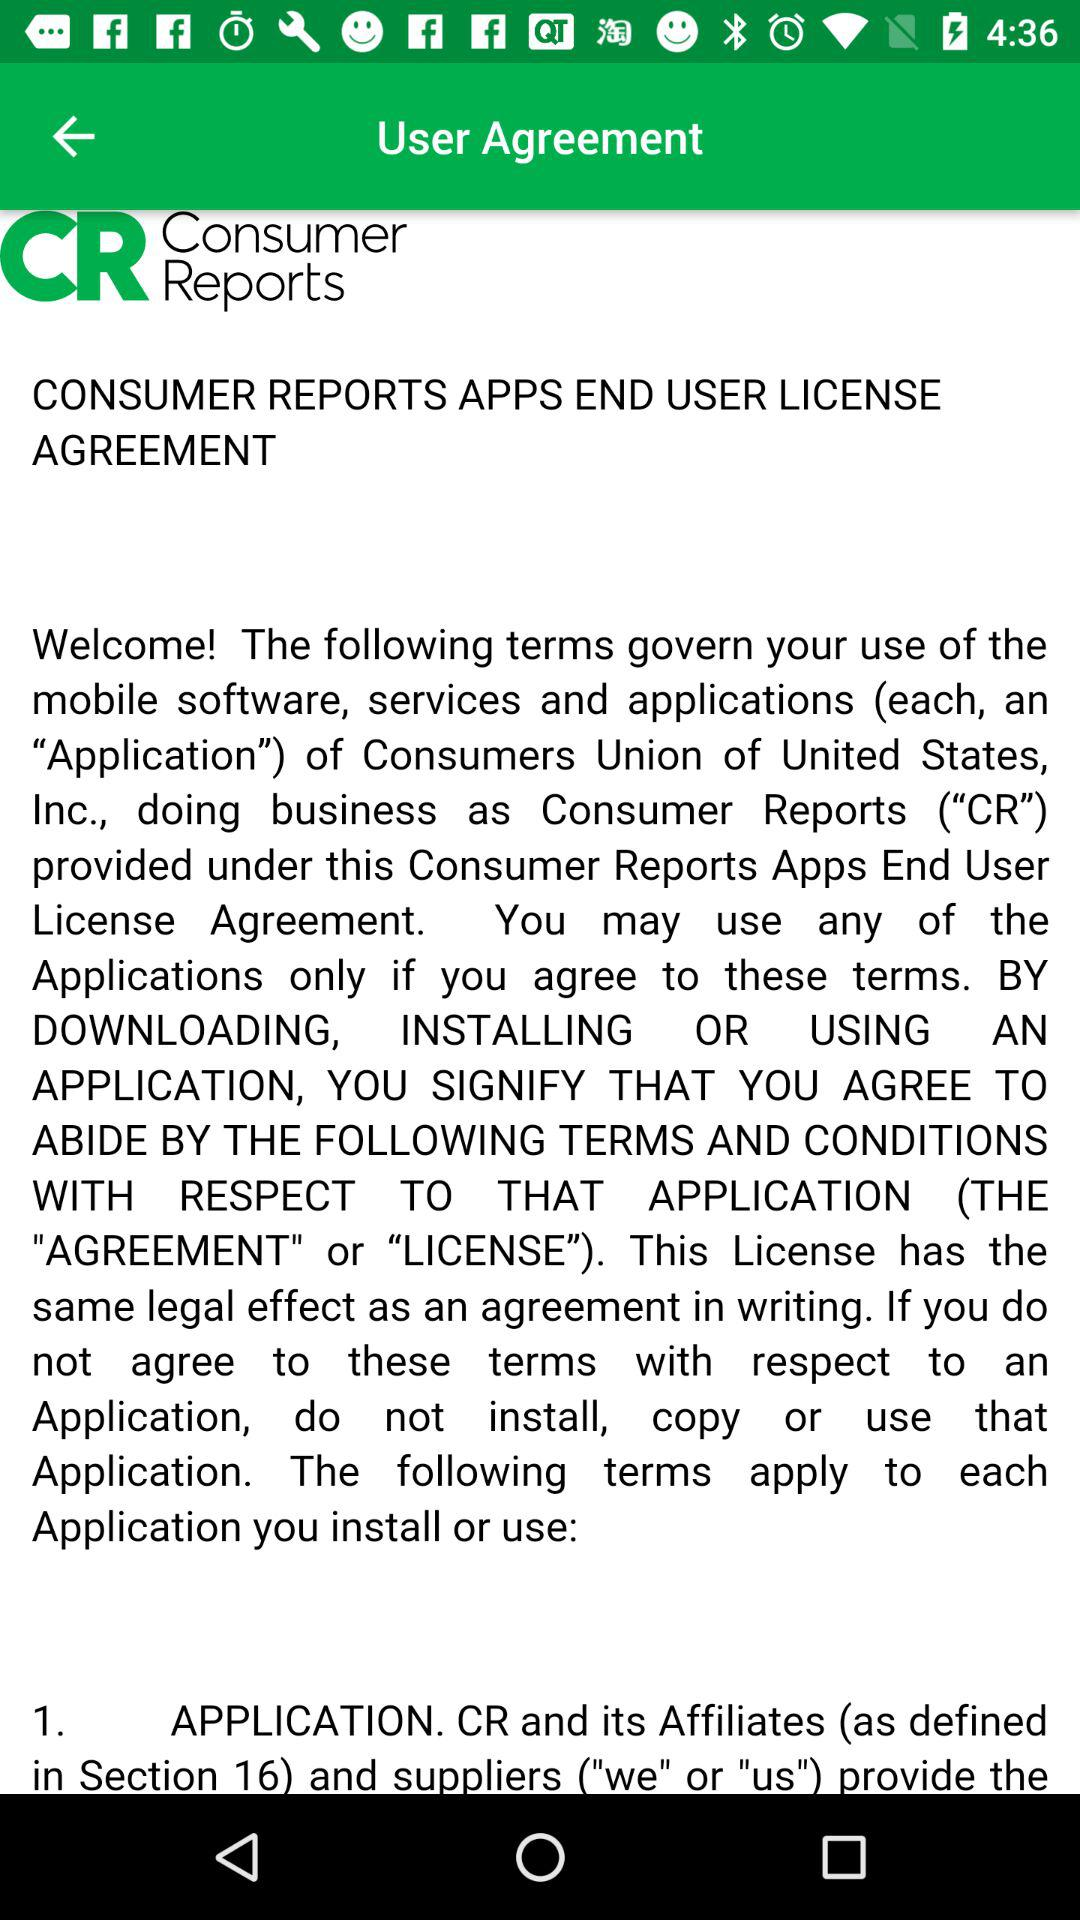What is the application name? The application name is "Consumer Reports". 